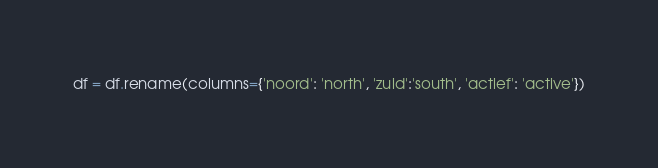<code> <loc_0><loc_0><loc_500><loc_500><_Python_>df = df.rename(columns={'noord': 'north', 'zuid':'south', 'actief': 'active'})</code> 